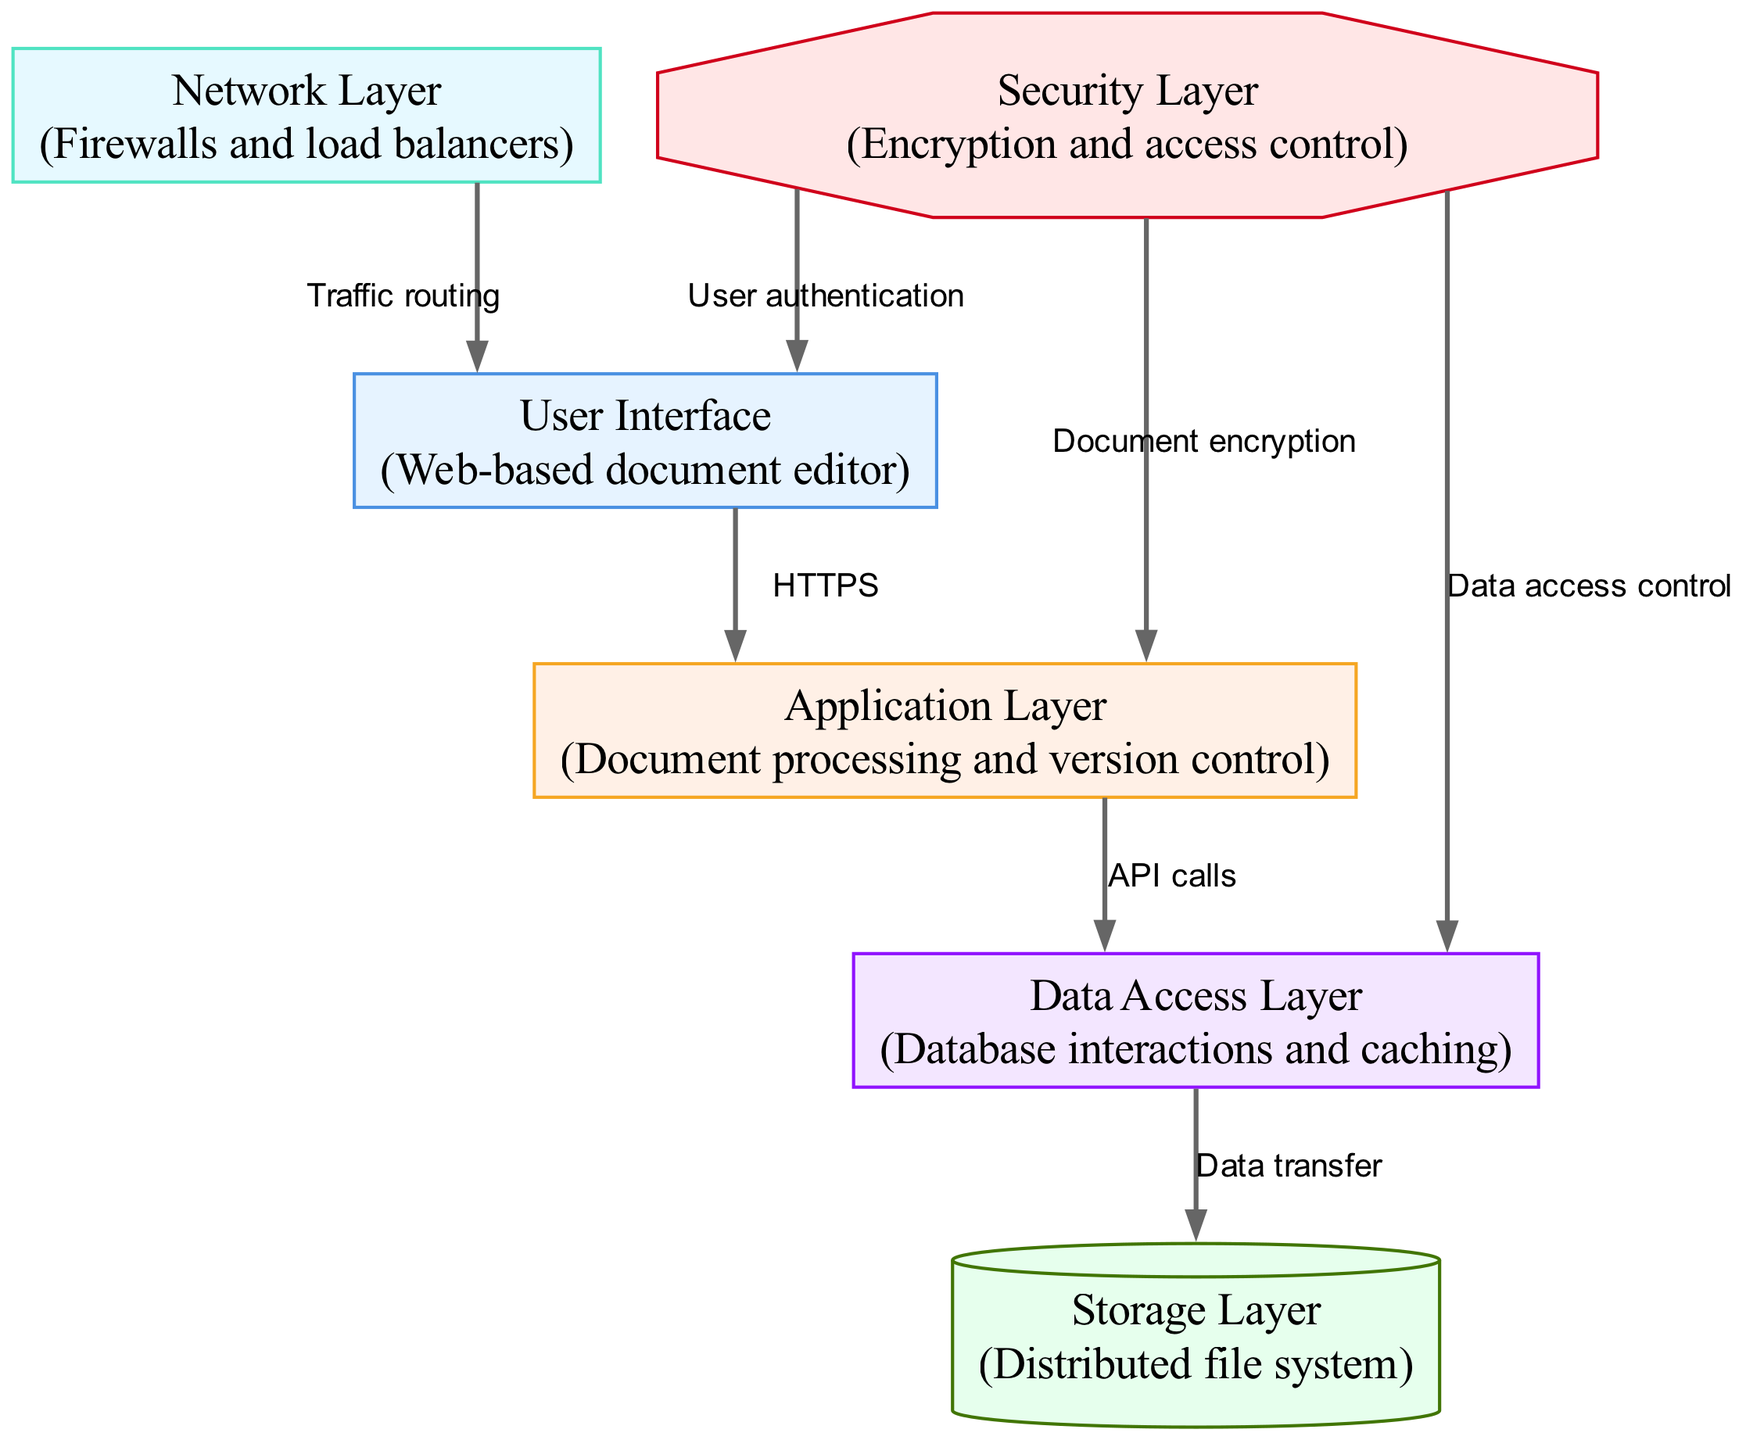What is the total number of nodes in the diagram? The diagram contains nodes that represent different layers of the multi-layered network. By counting each unique node listed in the data under "nodes", we determine that there are 6 nodes present in the diagram.
Answer: 6 Which layer is responsible for user authentication? The "Security Layer" is indicated to handle user authentication, as it has a direct edge to the "User Interface" node labeled "User authentication." This relationship shows that the security layer ensures that users are properly authenticated before they can access the system through the user interface.
Answer: Security Layer What type of connection is between the Application Layer and the Data Access Layer? The connection between the "Application Layer" and the "Data Access Layer" is established through "API calls," as labeled on the directed edge connecting the two nodes. This indicates that the application layer communicates with data access functionalities through these application programming interfaces.
Answer: API calls How many edges connect to the Storage Layer? By reviewing the edges in the diagram, we can observe that there is only one edge connecting to the "Storage Layer," which is the edge from the "Data Access Layer" labeled "Data transfer." This shows that the only interaction with the storage involves data being transferred to it from the data access functionality.
Answer: 1 Which layer interacts with the Network Layer for traffic routing? The "User Interface" interacts with the "Network Layer" for traffic routing, as indicated by the directed edge between these two layers labeled "Traffic routing." This relationship suggests that the network layer is responsible for directing traffic originating from the user interface.
Answer: User Interface What is the purpose of the Security Layer in the context of document sharing? The purpose of the "Security Layer" is outlined through its functions such as document encryption, data access control, and user authentication. By assessing the edges that connect to the security layer, we see that it tries to protect document confidentiality and integrity by implementing these security measures across the various interacting components of the system.
Answer: Encryption and access control 